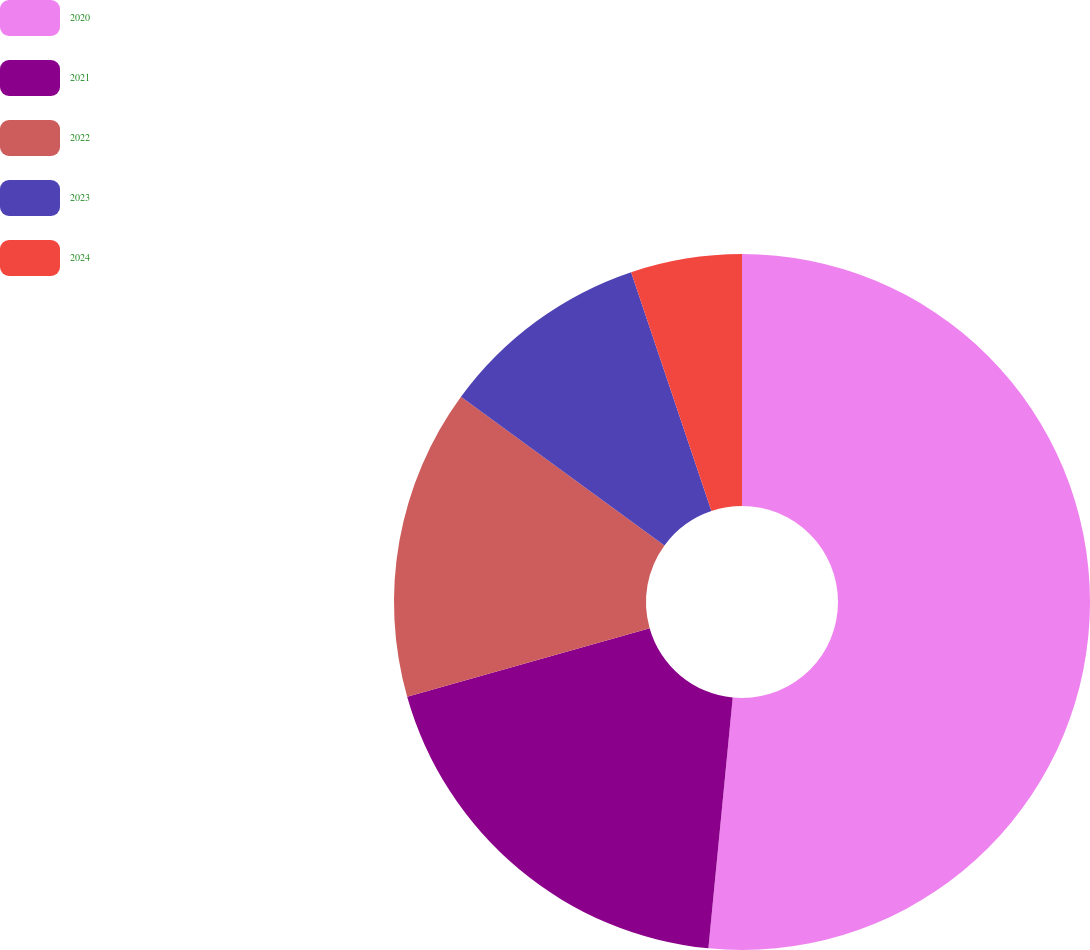<chart> <loc_0><loc_0><loc_500><loc_500><pie_chart><fcel>2020<fcel>2021<fcel>2022<fcel>2023<fcel>2024<nl><fcel>51.54%<fcel>19.07%<fcel>14.43%<fcel>9.8%<fcel>5.16%<nl></chart> 